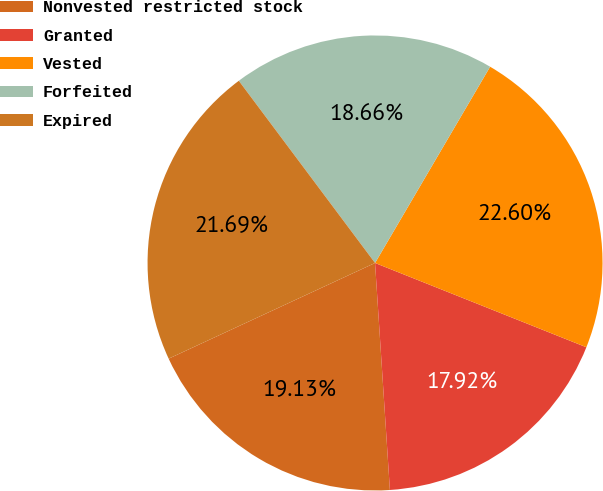Convert chart. <chart><loc_0><loc_0><loc_500><loc_500><pie_chart><fcel>Nonvested restricted stock<fcel>Granted<fcel>Vested<fcel>Forfeited<fcel>Expired<nl><fcel>19.13%<fcel>17.92%<fcel>22.6%<fcel>18.66%<fcel>21.69%<nl></chart> 